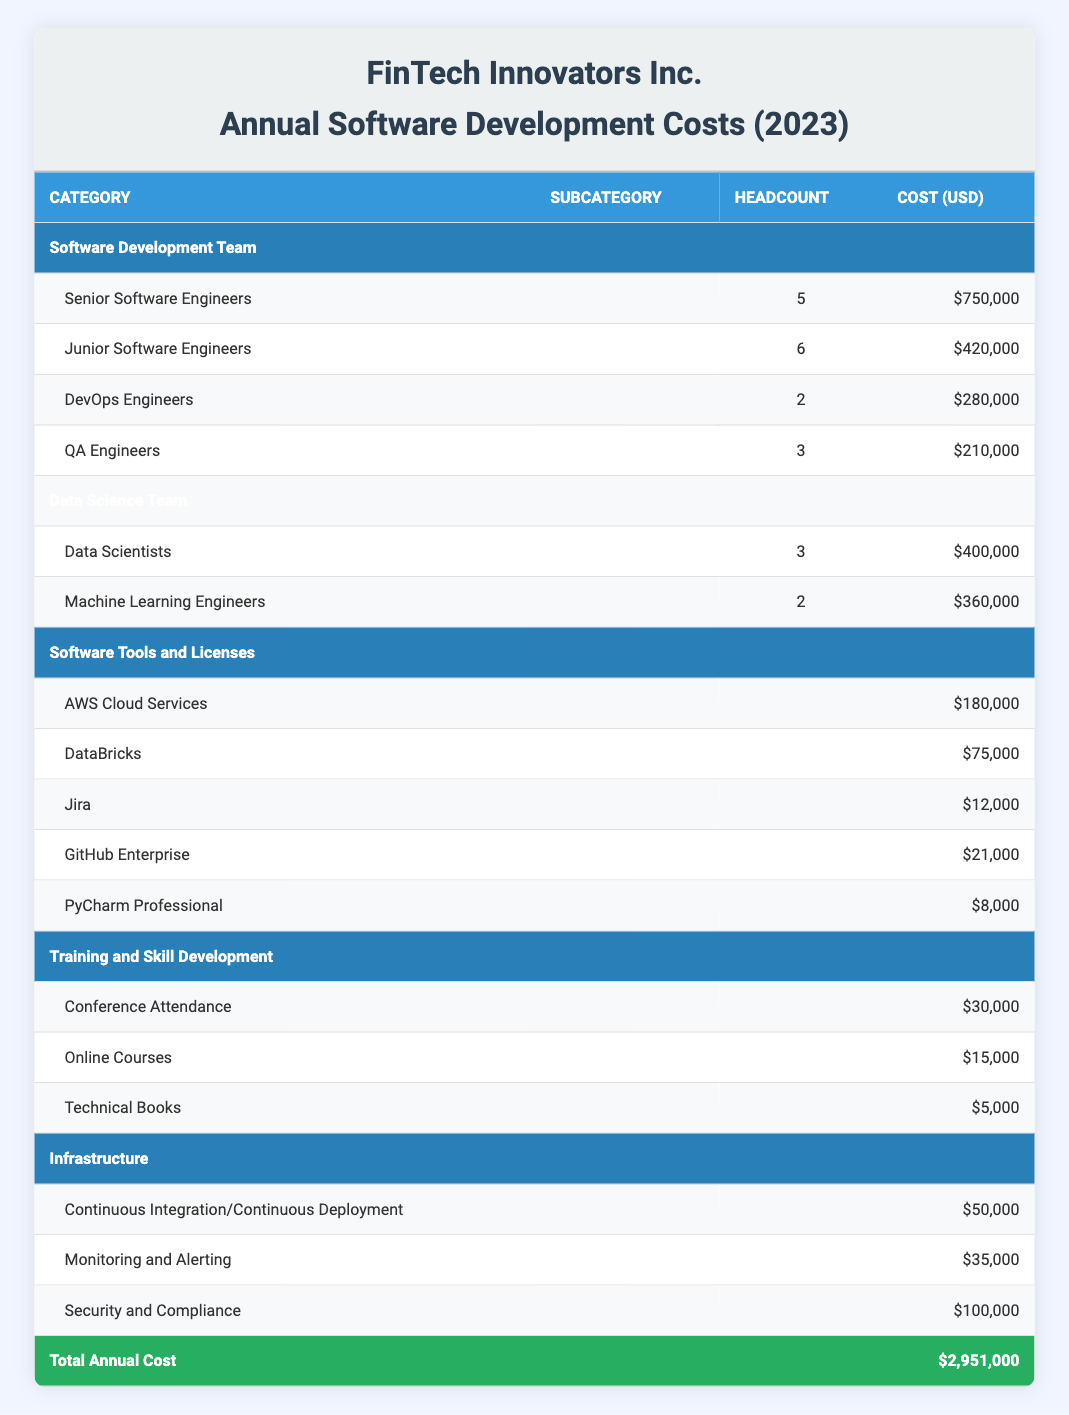What is the total annual cost of software development for the company? The total annual cost is clearly listed in the table under the "Total Annual Cost" row. It states $2,951,000.
Answer: $2,951,000 How many Junior Software Engineers are part of the Software Development Team? The headcount for Junior Software Engineers is found in the "Software Development Team" section. It shows a value of 6.
Answer: 6 What is the combined cost of the AWS Cloud Services and DataBricks? To find the combined cost, we need to add the costs of AWS Cloud Services ($180,000) and DataBricks ($75,000). The calculation is $180,000 + $75,000 = $255,000.
Answer: $255,000 Are there more Senior Software Engineers than DevOps Engineers? The table lists 5 Senior Software Engineers and 2 DevOps Engineers, so 5 is greater than 2, confirming the statement is true.
Answer: Yes What is the average cost per Data Scientist in the Data Science Team? The total cost for Data Scientists is $400,000, and there are 3 Data Scientists. To find the average, divide the total cost by the headcount: $400,000 / 3 = $133,333.33.
Answer: $133,333.33 What category has the highest total cost? Reviewing the categories in the table, the Software Development Team shows a total cost of $1,660,000, which is higher than any other category's total costs (Data Science Team: $760,000, Software Tools and Licenses: $296,000, Training and Skill Development: $50,000, and Infrastructure: $185,000). Therefore, the Software Development Team has the highest total cost.
Answer: Software Development Team If the combined training costs for Conference Attendance, Online Courses, and Technical Books are considered, what is the total? The costs are Conference Attendance ($30,000), Online Courses ($15,000), and Technical Books ($5,000). Adding these together gives $30,000 + $15,000 + $5,000 = $50,000.
Answer: $50,000 Is the cost for Security and Compliance greater than the combined cost of Continuous Integration/Continuous Deployment and Monitoring and Alerting? The cost for Security and Compliance is $100,000. The combined cost of Continuous Integration/Continuous Deployment ($50,000) and Monitoring and Alerting ($35,000) is $50,000 + $35,000 = $85,000. Since $100,000 is greater than $85,000, the statement is true.
Answer: Yes How many DevOps Engineers and QA Engineers are there in total? Summing the headcounts, there are 2 DevOps Engineers and 3 QA Engineers. Therefore, 2 + 3 = 5.
Answer: 5 